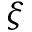Convert formula to latex. <formula><loc_0><loc_0><loc_500><loc_500>\xi</formula> 